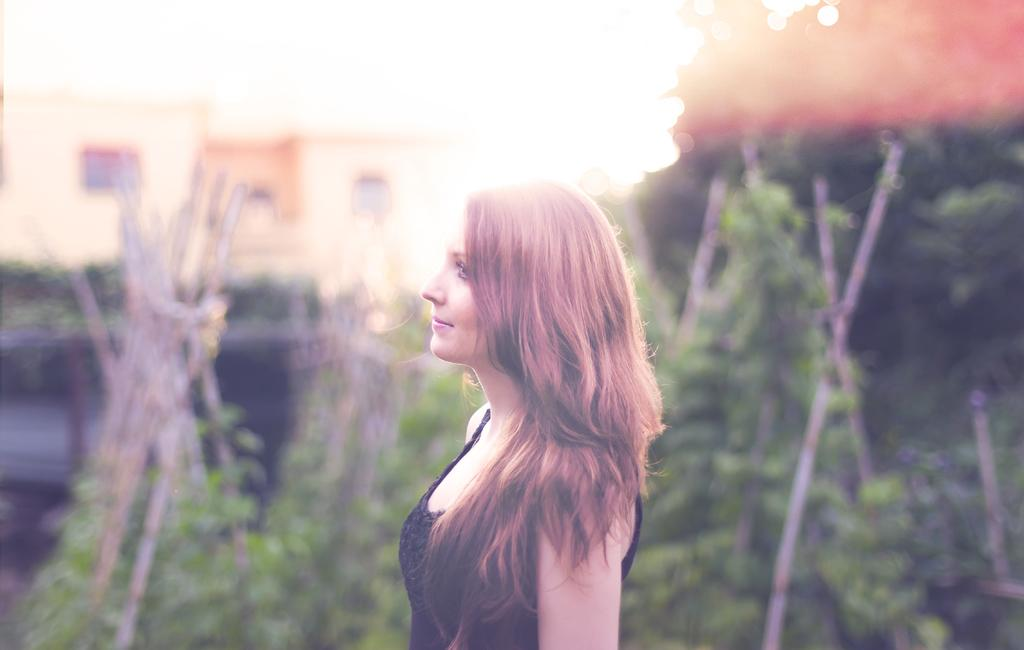Who is the main subject in the image? There is a girl in the image. Where is the girl located in the image? The girl is in the middle of the image. What can be seen in the background of the image? There are plants and buildings in the background of the image. How many bushes are visible in the image? There is no mention of bushes in the provided facts, so we cannot determine the number of bushes in the image. Is the girl riding a bike in the image? There is no mention of a bike in the provided facts, so we cannot determine if the girl is riding a bike in the image. 